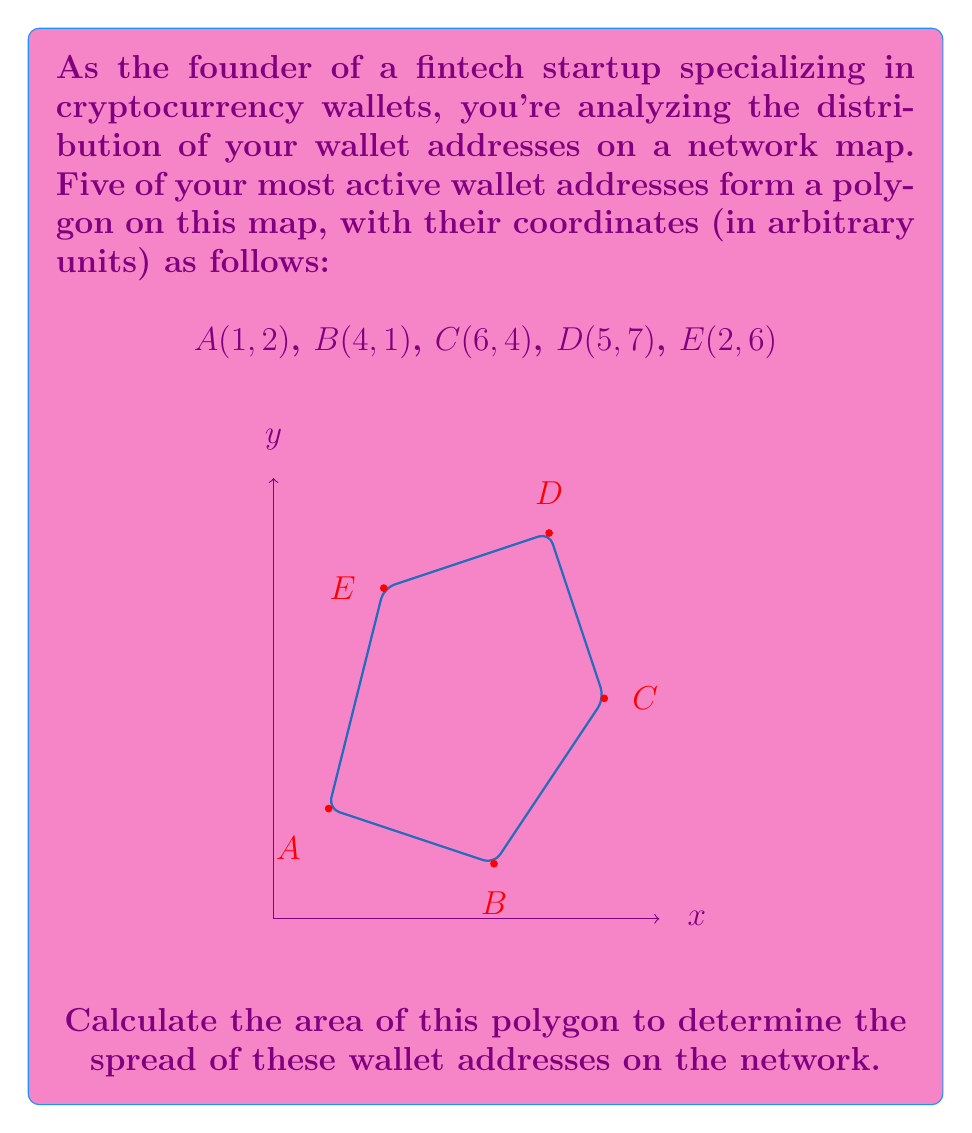Show me your answer to this math problem. To find the area of this irregular polygon, we can use the Shoelace formula (also known as the surveyor's formula). This formula calculates the area of a polygon given the coordinates of its vertices.

The Shoelace formula is:

$$ \text{Area} = \frac{1}{2}|\sum_{i=1}^{n-1} (x_iy_{i+1} + x_ny_1) - \sum_{i=1}^{n-1} (x_{i+1}y_i + x_1y_n)| $$

Where $(x_i, y_i)$ are the coordinates of the $i$-th vertex.

Let's apply this formula to our polygon:

1) First, let's organize our data:
   A(1, 2), B(4, 1), C(6, 4), D(5, 7), E(2, 6)

2) Now, let's calculate the first sum:
   $$(1 \cdot 1 + 4 \cdot 4 + 6 \cdot 7 + 5 \cdot 6 + 2 \cdot 2) = 1 + 16 + 42 + 30 + 4 = 93$$

3) Calculate the second sum:
   $$(4 \cdot 2 + 6 \cdot 1 + 5 \cdot 4 + 2 \cdot 7 + 1 \cdot 6) = 8 + 6 + 20 + 14 + 6 = 54$$

4) Subtract the second sum from the first:
   $$93 - 54 = 39$$

5) Take the absolute value (which doesn't change anything in this case) and divide by 2:
   $$\frac{|39|}{2} = \frac{39}{2} = 19.5$$

Therefore, the area of the polygon is 19.5 square units.
Answer: $$19.5\text{ square units}$$ 